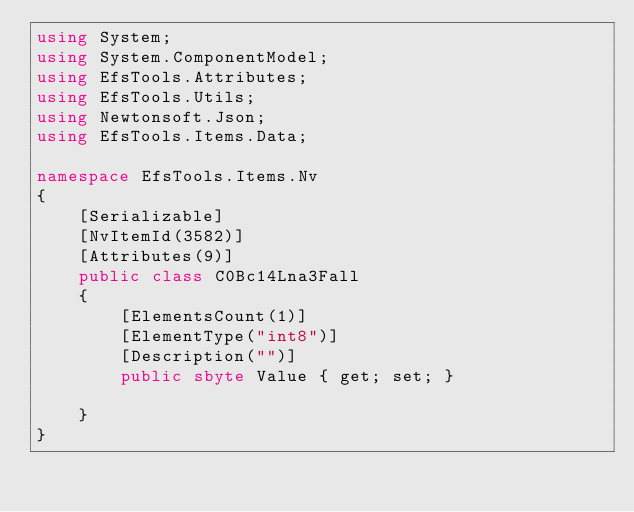<code> <loc_0><loc_0><loc_500><loc_500><_C#_>using System;
using System.ComponentModel;
using EfsTools.Attributes;
using EfsTools.Utils;
using Newtonsoft.Json;
using EfsTools.Items.Data;

namespace EfsTools.Items.Nv
{
    [Serializable]
    [NvItemId(3582)]
    [Attributes(9)]
    public class C0Bc14Lna3Fall
    {
        [ElementsCount(1)]
        [ElementType("int8")]
        [Description("")]
        public sbyte Value { get; set; }
        
    }
}
</code> 